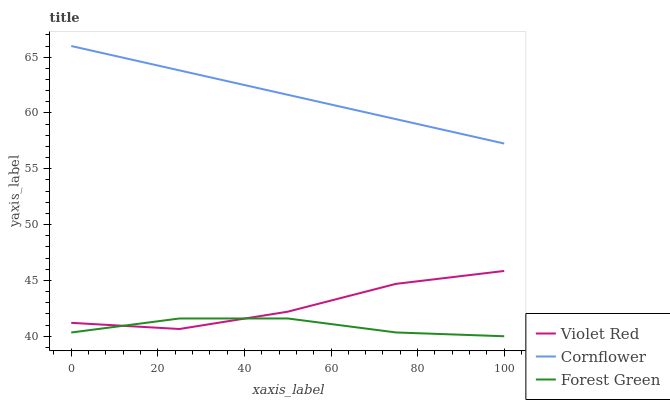Does Forest Green have the minimum area under the curve?
Answer yes or no. Yes. Does Cornflower have the maximum area under the curve?
Answer yes or no. Yes. Does Violet Red have the minimum area under the curve?
Answer yes or no. No. Does Violet Red have the maximum area under the curve?
Answer yes or no. No. Is Cornflower the smoothest?
Answer yes or no. Yes. Is Violet Red the roughest?
Answer yes or no. Yes. Is Forest Green the smoothest?
Answer yes or no. No. Is Forest Green the roughest?
Answer yes or no. No. Does Violet Red have the lowest value?
Answer yes or no. No. Does Cornflower have the highest value?
Answer yes or no. Yes. Does Violet Red have the highest value?
Answer yes or no. No. Is Violet Red less than Cornflower?
Answer yes or no. Yes. Is Cornflower greater than Violet Red?
Answer yes or no. Yes. Does Forest Green intersect Violet Red?
Answer yes or no. Yes. Is Forest Green less than Violet Red?
Answer yes or no. No. Is Forest Green greater than Violet Red?
Answer yes or no. No. Does Violet Red intersect Cornflower?
Answer yes or no. No. 